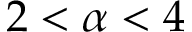Convert formula to latex. <formula><loc_0><loc_0><loc_500><loc_500>2 < \alpha < 4</formula> 